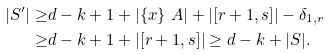<formula> <loc_0><loc_0><loc_500><loc_500>| S ^ { \prime } | \geq & d - k + 1 + | \{ x \} \ A | + | [ r + 1 , s ] | - \delta _ { 1 , r } \\ \geq & d - k + 1 + | [ r + 1 , s ] | \geq d - k + | S | .</formula> 